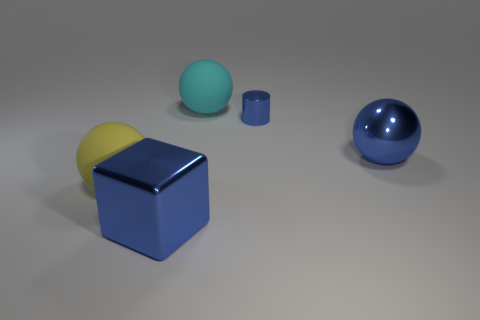What number of other objects are there of the same size as the yellow object?
Offer a terse response. 3. Does the large shiny block have the same color as the big object that is to the right of the metal cylinder?
Ensure brevity in your answer.  Yes. What number of things are either small metal objects or big purple metallic things?
Provide a succinct answer. 1. Is there anything else that has the same color as the large metal block?
Your answer should be very brief. Yes. Does the blue cylinder have the same material as the blue object that is in front of the big shiny ball?
Your answer should be very brief. Yes. What shape is the matte thing that is right of the rubber object that is in front of the blue ball?
Give a very brief answer. Sphere. There is a blue metallic object that is both behind the yellow object and in front of the blue metallic cylinder; what is its shape?
Your answer should be compact. Sphere. What number of objects are large blue metallic cylinders or things that are behind the yellow matte object?
Your answer should be very brief. 3. There is a big blue object that is the same shape as the yellow rubber object; what material is it?
Your response must be concise. Metal. What material is the object that is behind the block and left of the big cyan ball?
Make the answer very short. Rubber. 